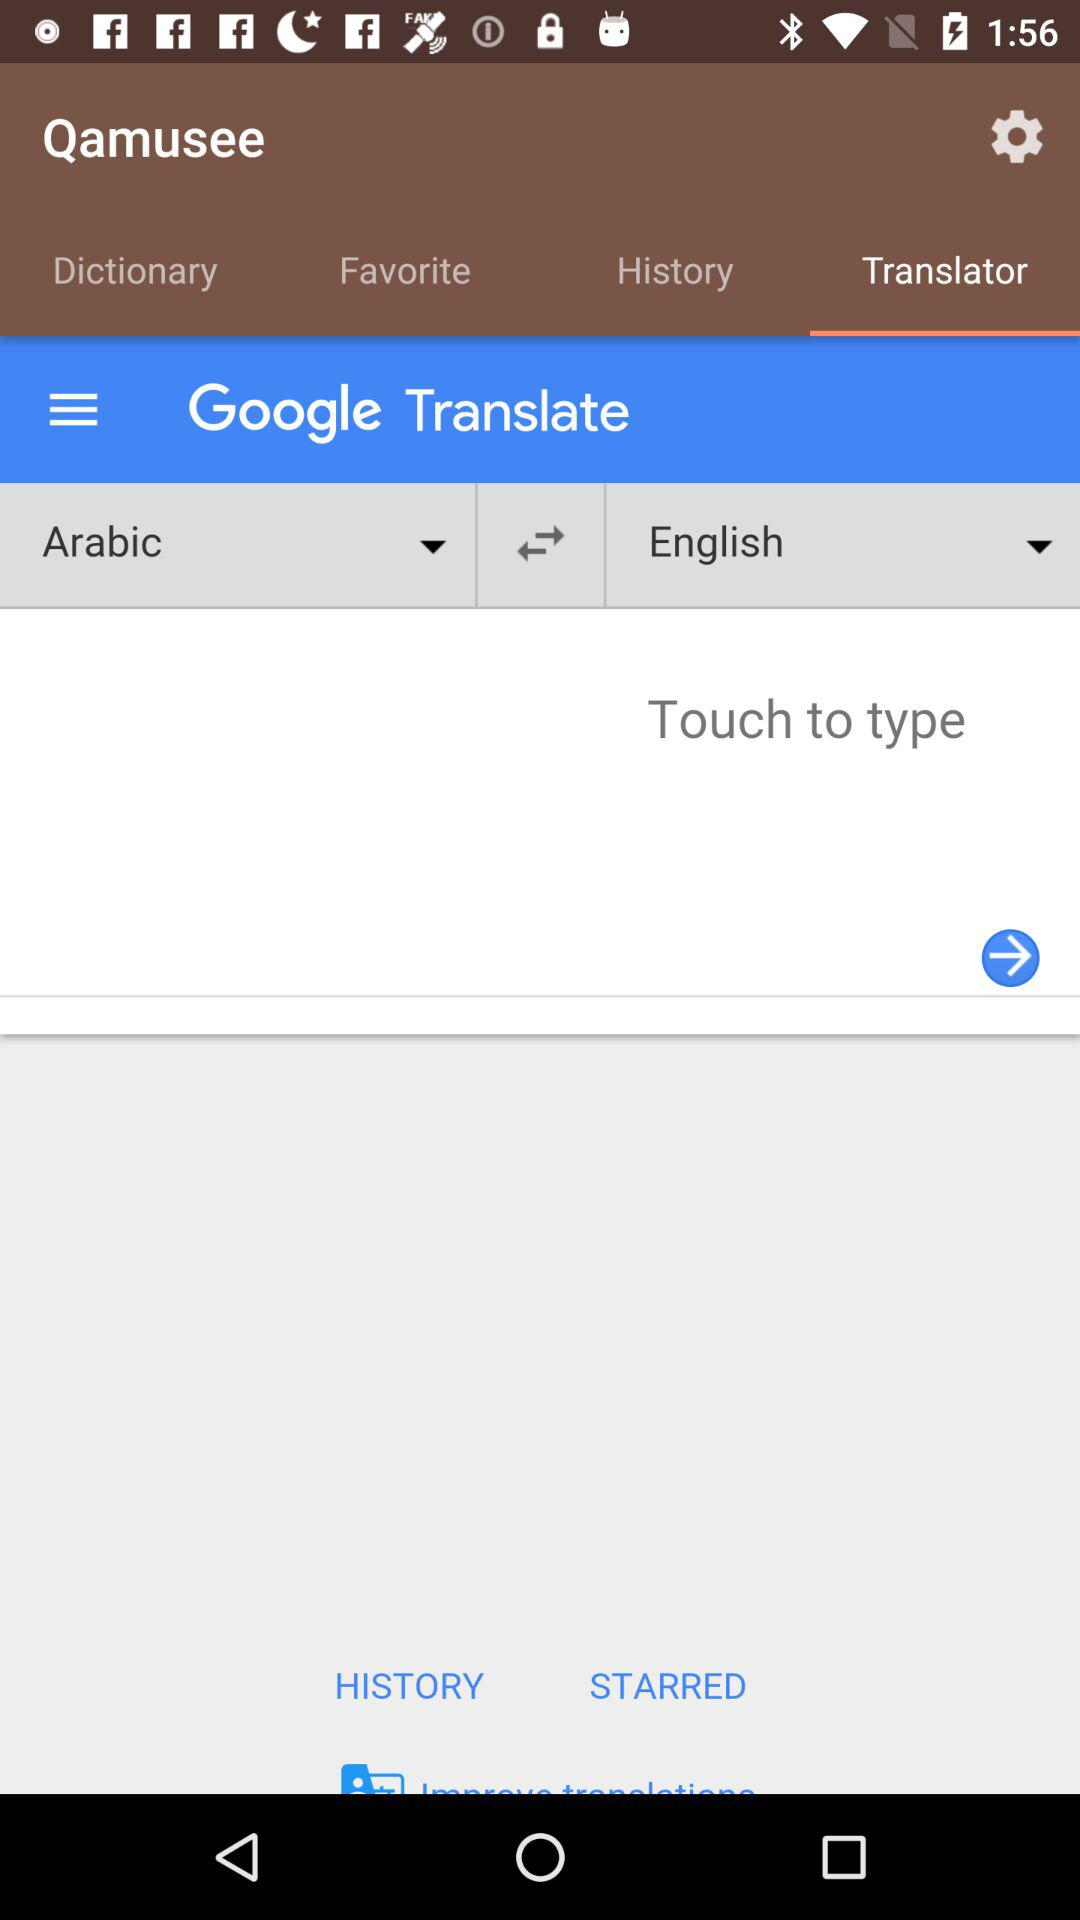Which tab has been selected? The selected tab is "Translator". 